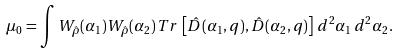<formula> <loc_0><loc_0><loc_500><loc_500>\mu _ { 0 } = \int W _ { \hat { \rho } } ( \alpha _ { 1 } ) W _ { \hat { \rho } } ( \alpha _ { 2 } ) \, T r \, \left [ \hat { D } ( \alpha _ { 1 } , q ) , \hat { D } ( \alpha _ { 2 } , q ) \right ] \, d ^ { 2 } \alpha _ { 1 } \, d ^ { 2 } \alpha _ { 2 } .</formula> 